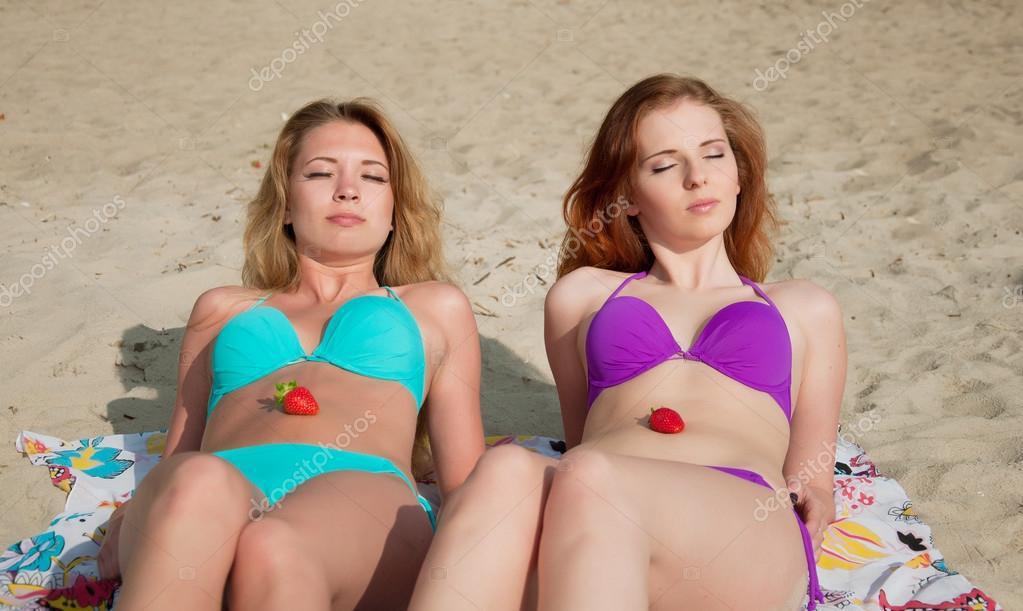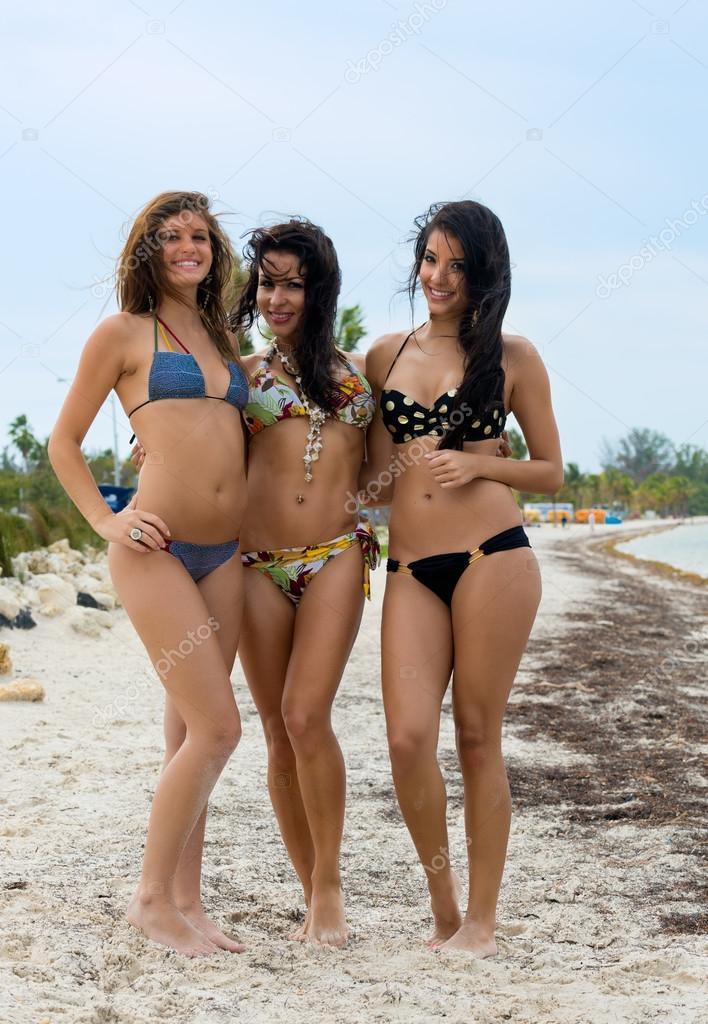The first image is the image on the left, the second image is the image on the right. Assess this claim about the two images: "A female is wearing a yellow bikini.". Correct or not? Answer yes or no. No. The first image is the image on the left, the second image is the image on the right. Assess this claim about the two images: "At least one woman has her hand on her hips.". Correct or not? Answer yes or no. Yes. 